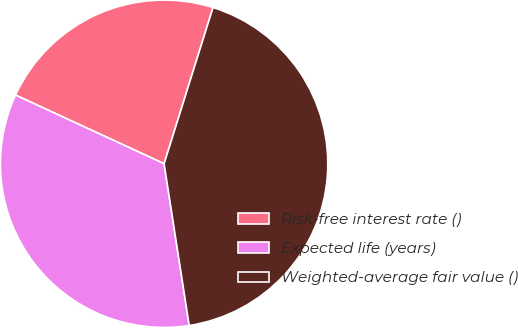Convert chart to OTSL. <chart><loc_0><loc_0><loc_500><loc_500><pie_chart><fcel>Risk-free interest rate ()<fcel>Expected life (years)<fcel>Weighted-average fair value ()<nl><fcel>22.94%<fcel>34.34%<fcel>42.72%<nl></chart> 